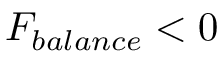Convert formula to latex. <formula><loc_0><loc_0><loc_500><loc_500>F _ { b a l a n c e } < 0</formula> 